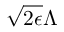<formula> <loc_0><loc_0><loc_500><loc_500>\sqrt { 2 \epsilon } { \Lambda }</formula> 